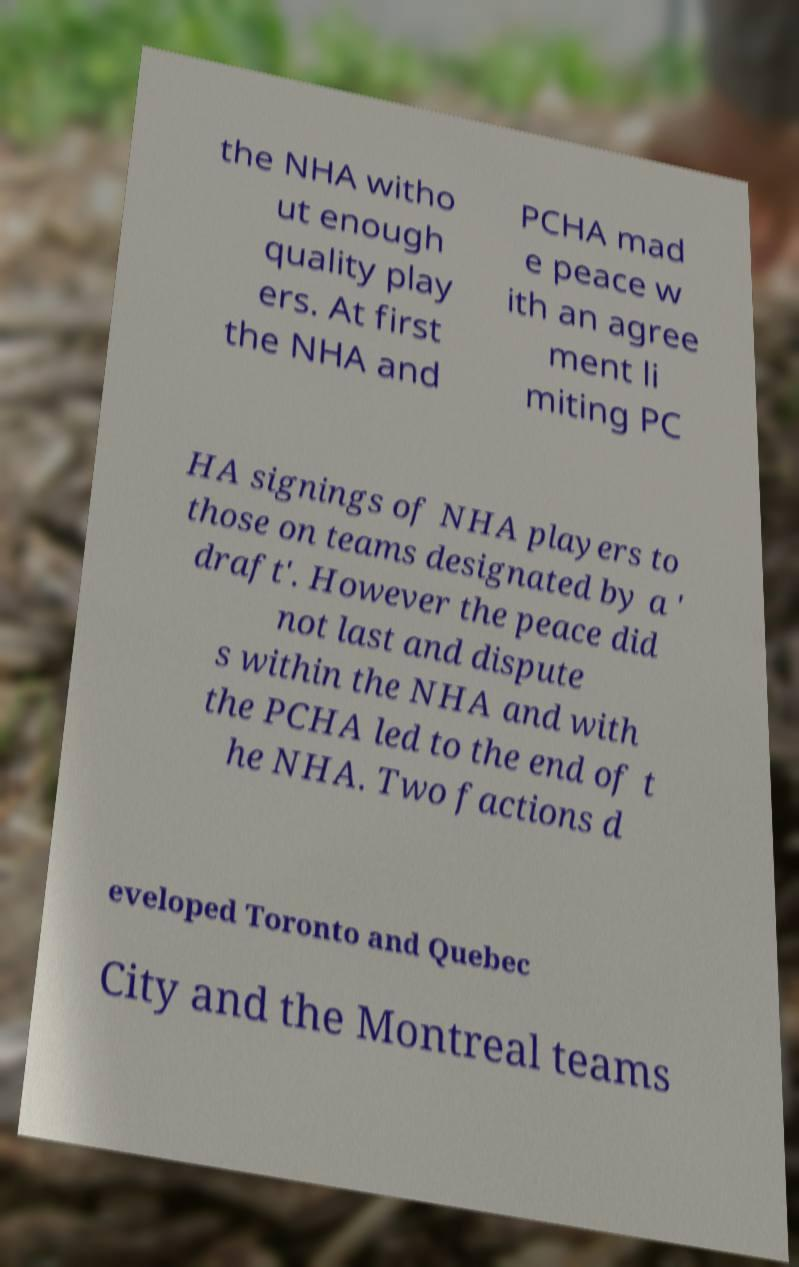There's text embedded in this image that I need extracted. Can you transcribe it verbatim? the NHA witho ut enough quality play ers. At first the NHA and PCHA mad e peace w ith an agree ment li miting PC HA signings of NHA players to those on teams designated by a ' draft'. However the peace did not last and dispute s within the NHA and with the PCHA led to the end of t he NHA. Two factions d eveloped Toronto and Quebec City and the Montreal teams 